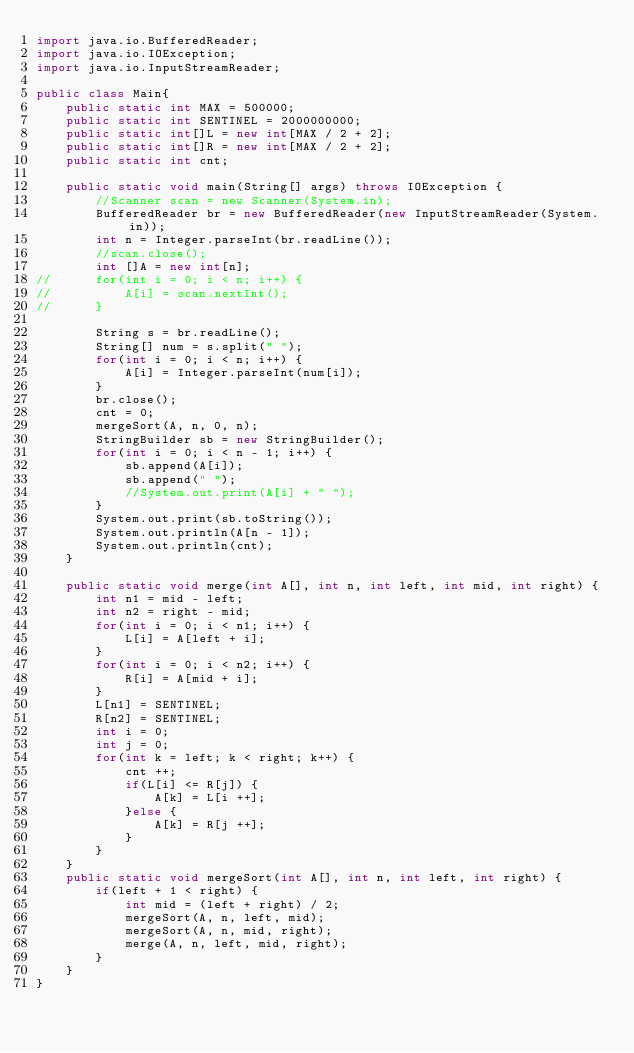Convert code to text. <code><loc_0><loc_0><loc_500><loc_500><_Java_>import java.io.BufferedReader;
import java.io.IOException;
import java.io.InputStreamReader;

public class Main{
	public static int MAX = 500000;
	public static int SENTINEL = 2000000000;
	public static int[]L = new int[MAX / 2 + 2];
	public static int[]R = new int[MAX / 2 + 2];
	public static int cnt;

	public static void main(String[] args) throws IOException {
		//Scanner scan = new Scanner(System.in);
		BufferedReader br = new BufferedReader(new InputStreamReader(System.in));
		int n = Integer.parseInt(br.readLine());
		//scan.close();
		int []A = new int[n];
//		for(int i = 0; i < n; i++) {
//			A[i] = scan.nextInt();
//		}

		String s = br.readLine();
		String[] num = s.split(" ");
		for(int i = 0; i < n; i++) {
			A[i] = Integer.parseInt(num[i]);
		}
		br.close();
		cnt = 0;
		mergeSort(A, n, 0, n);
		StringBuilder sb = new StringBuilder();
		for(int i = 0; i < n - 1; i++) {
			sb.append(A[i]);
			sb.append(" ");
			//System.out.print(A[i] + " ");
		}
		System.out.print(sb.toString());
		System.out.println(A[n - 1]);
		System.out.println(cnt);
	}

	public static void merge(int A[], int n, int left, int mid, int right) {
		int n1 = mid - left;
		int n2 = right - mid;
		for(int i = 0; i < n1; i++) {
			L[i] = A[left + i];
		}
		for(int i = 0; i < n2; i++) {
			R[i] = A[mid + i];
		}
		L[n1] = SENTINEL;
		R[n2] = SENTINEL;
		int i = 0;
		int j = 0;
		for(int k = left; k < right; k++) {
			cnt ++;
			if(L[i] <= R[j]) {
				A[k] = L[i ++];
			}else {
				A[k] = R[j ++];
			}
		}
	}
	public static void mergeSort(int A[], int n, int left, int right) {
		if(left + 1 < right) {
			int mid = (left + right) / 2;
			mergeSort(A, n, left, mid);
			mergeSort(A, n, mid, right);
			merge(A, n, left, mid, right);
		}
	}
}
</code> 